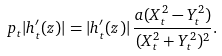<formula> <loc_0><loc_0><loc_500><loc_500>\ p _ { t } | h _ { t } ^ { \prime } ( z ) | = | h _ { t } ^ { \prime } ( z ) | \, \frac { a ( X ^ { 2 } _ { t } - Y _ { t } ^ { 2 } ) } { ( X _ { t } ^ { 2 } + Y _ { t } ^ { 2 } ) ^ { 2 } } .</formula> 